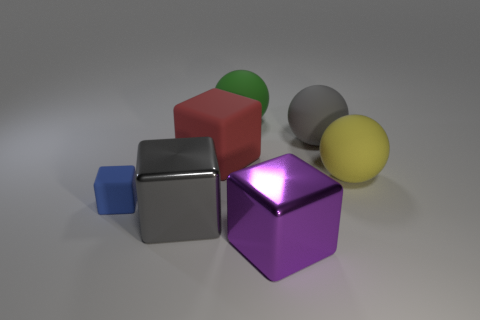Add 2 big rubber cubes. How many objects exist? 9 Subtract all large cubes. How many cubes are left? 1 Subtract all yellow balls. How many balls are left? 2 Subtract 1 blocks. How many blocks are left? 3 Subtract all red blocks. Subtract all gray spheres. How many blocks are left? 3 Subtract all blue spheres. How many purple blocks are left? 1 Subtract all large shiny cubes. Subtract all tiny matte cubes. How many objects are left? 4 Add 2 purple metallic objects. How many purple metallic objects are left? 3 Add 4 big gray metallic cubes. How many big gray metallic cubes exist? 5 Subtract 1 gray spheres. How many objects are left? 6 